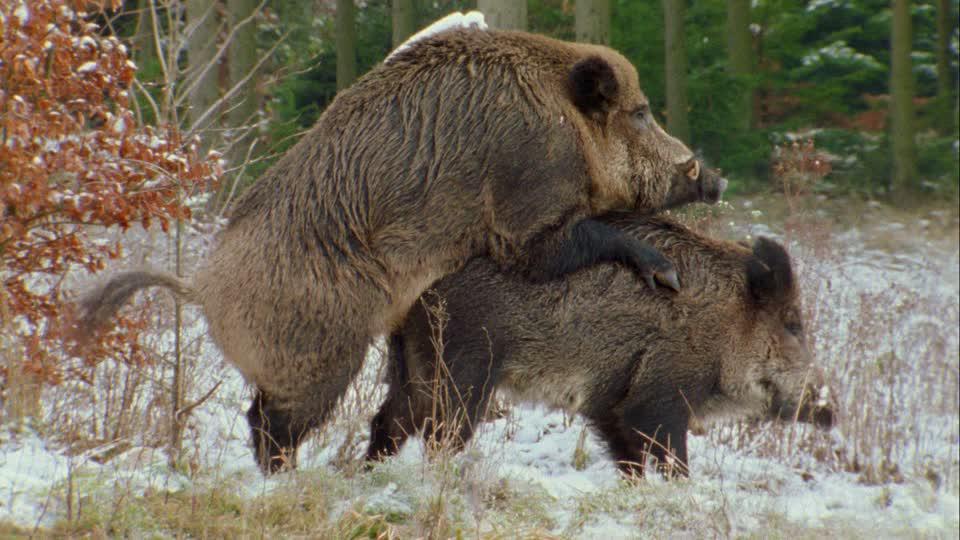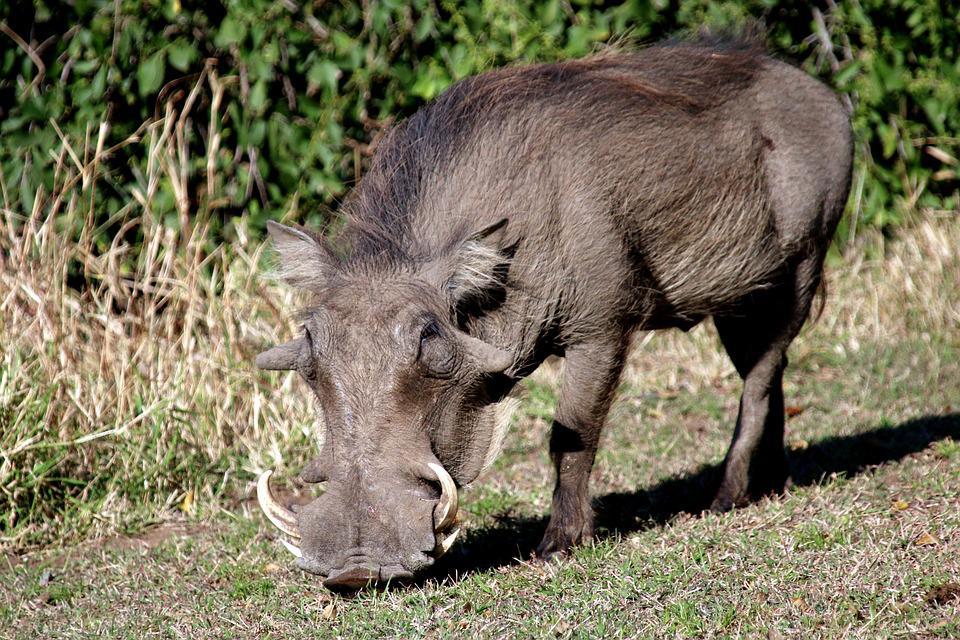The first image is the image on the left, the second image is the image on the right. Analyze the images presented: Is the assertion "there is one hog on the right image standing" valid? Answer yes or no. Yes. 